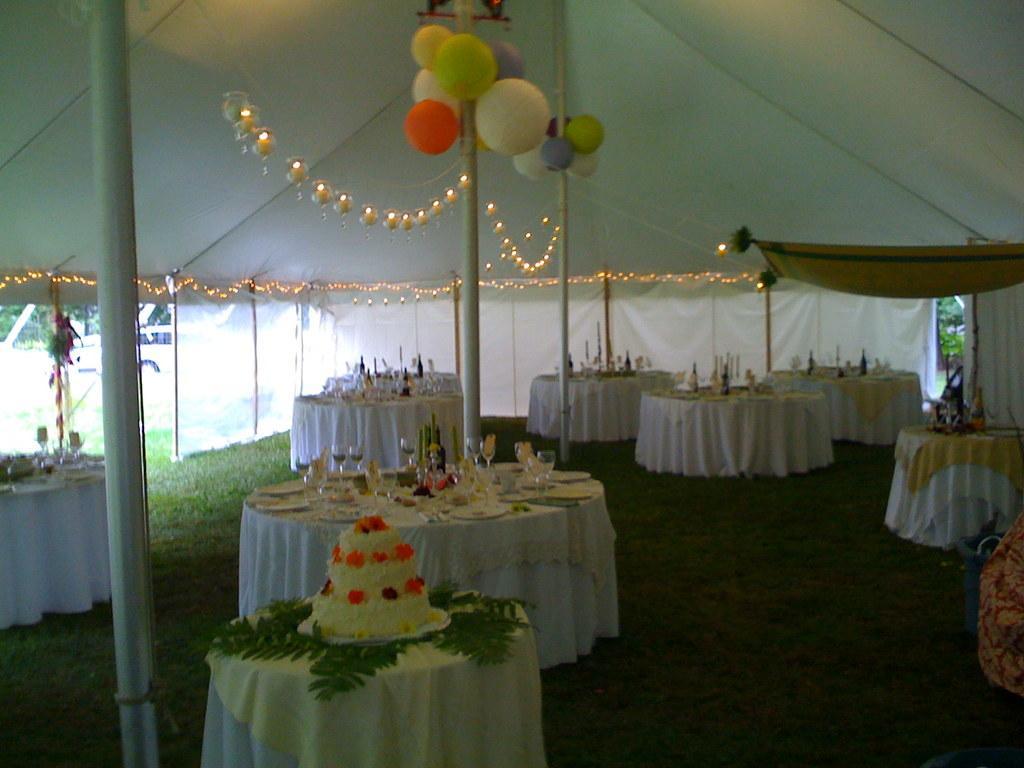Could you give a brief overview of what you see in this image? In this image I can see the ground, few tables on the ground and on the tables I can see a cake, few plates, few glasses and few other objects. I can see few metal poles, few balloons, few lights, few flowers and white colored tent. In the background I can see few trees and a car on the ground. 